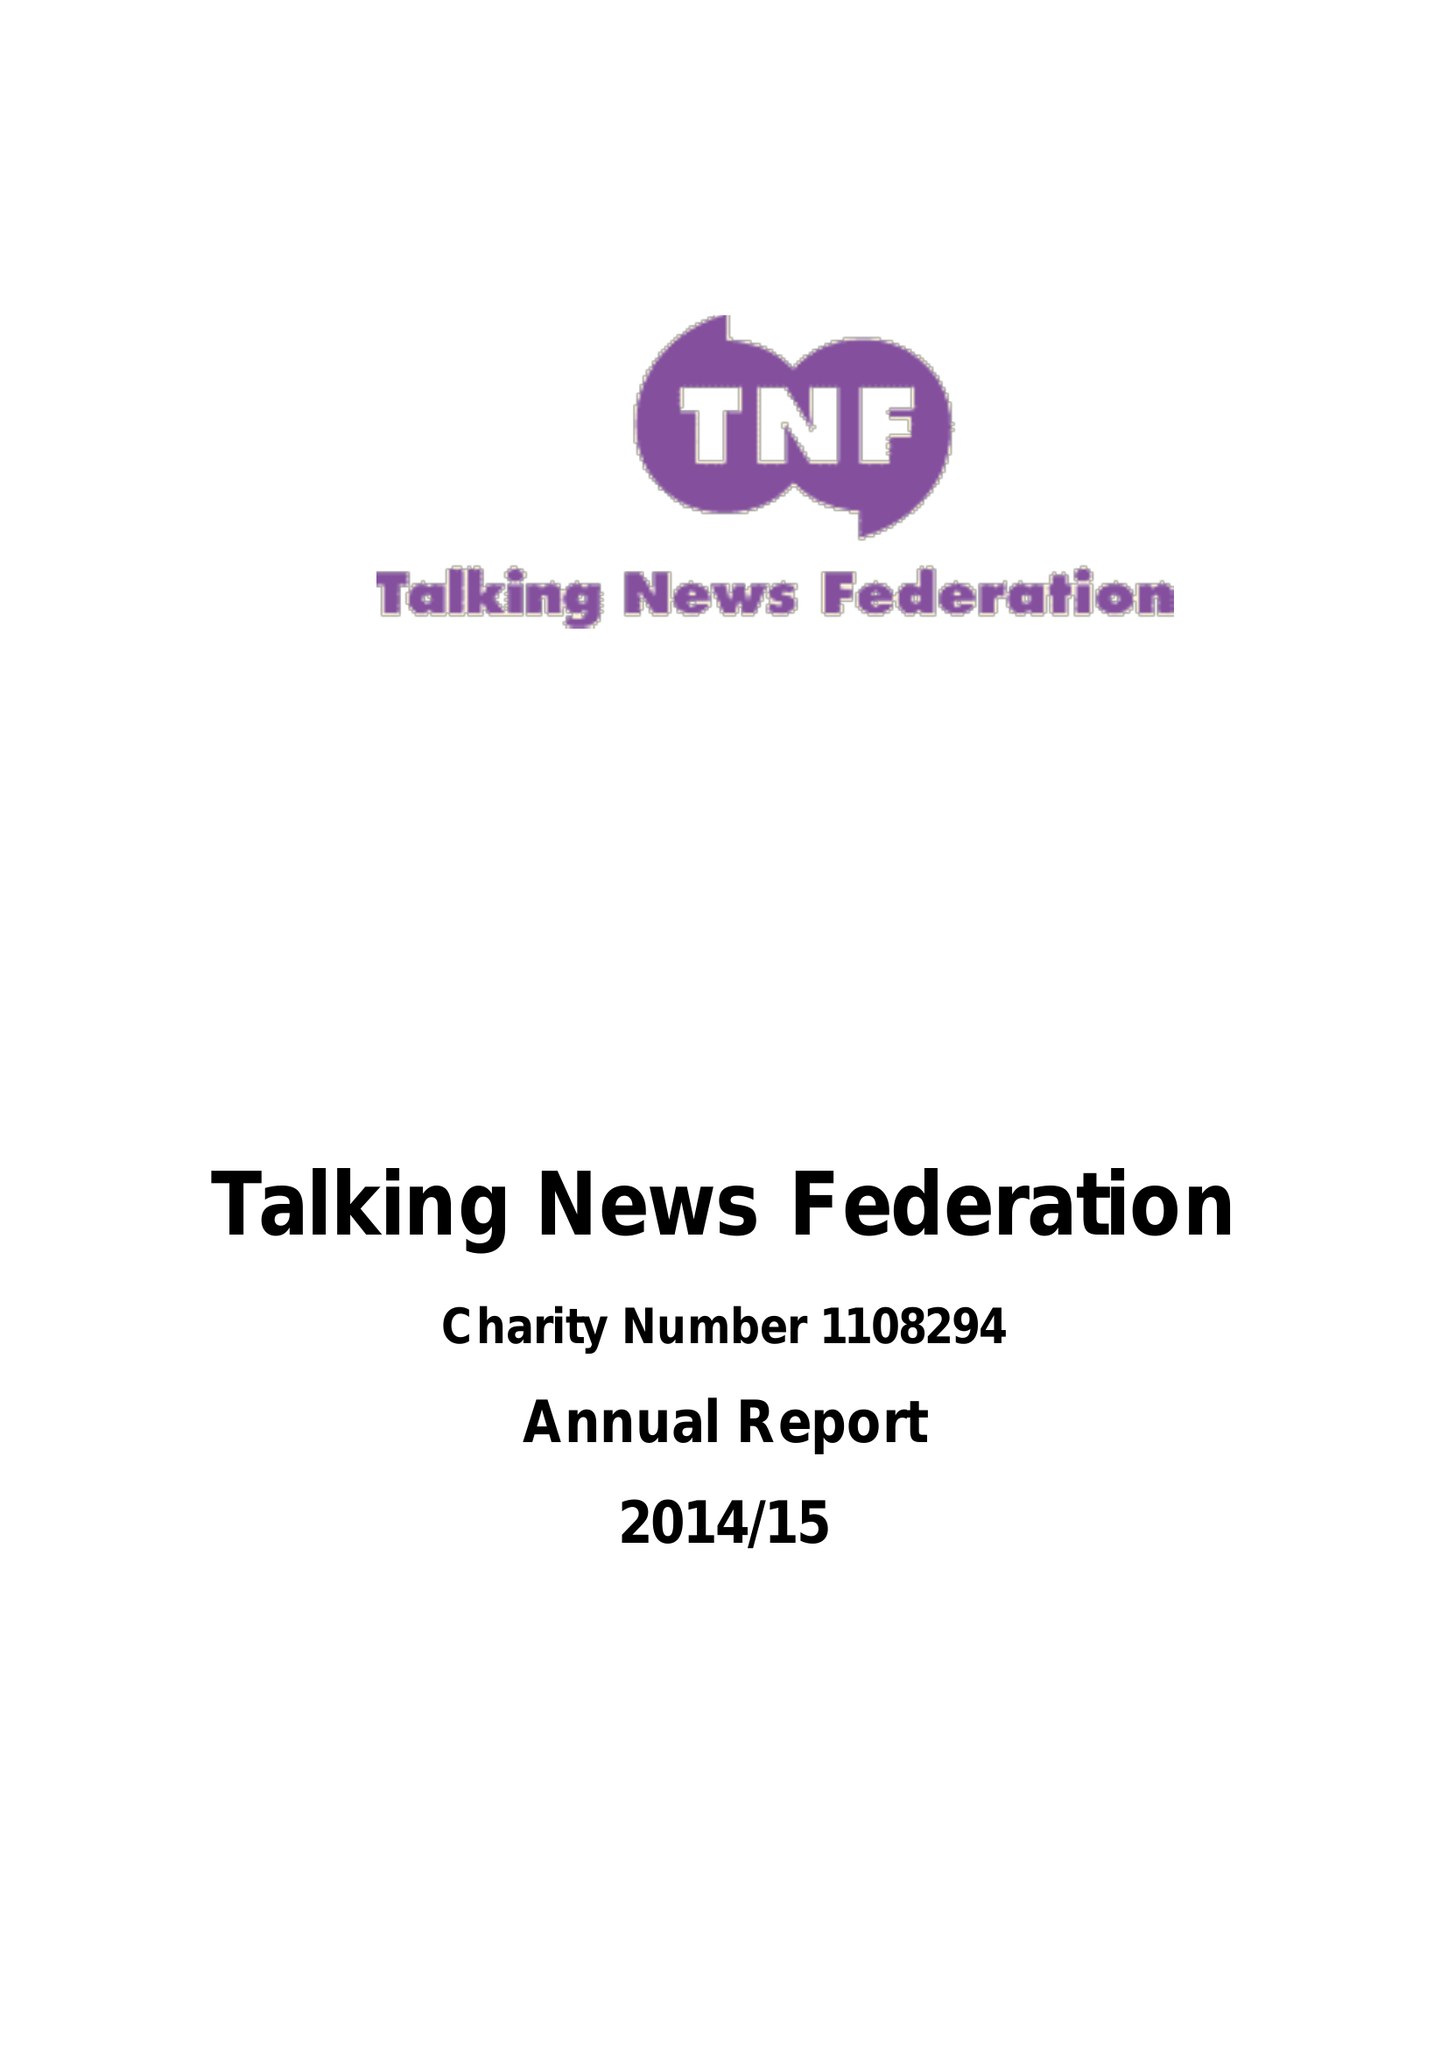What is the value for the charity_number?
Answer the question using a single word or phrase. 1108294 